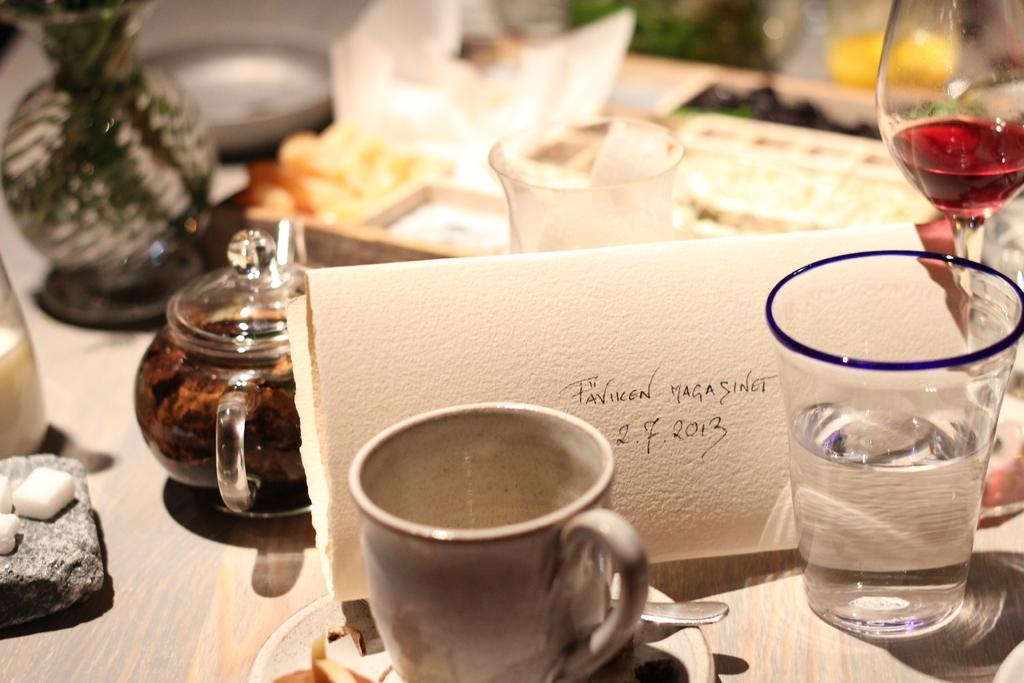In one or two sentences, can you explain what this image depicts? I can see in this image there are few cups glasses and other objects. 